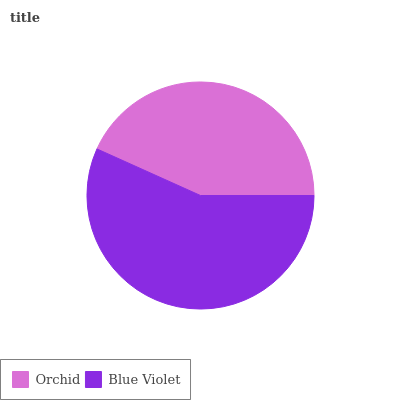Is Orchid the minimum?
Answer yes or no. Yes. Is Blue Violet the maximum?
Answer yes or no. Yes. Is Blue Violet the minimum?
Answer yes or no. No. Is Blue Violet greater than Orchid?
Answer yes or no. Yes. Is Orchid less than Blue Violet?
Answer yes or no. Yes. Is Orchid greater than Blue Violet?
Answer yes or no. No. Is Blue Violet less than Orchid?
Answer yes or no. No. Is Blue Violet the high median?
Answer yes or no. Yes. Is Orchid the low median?
Answer yes or no. Yes. Is Orchid the high median?
Answer yes or no. No. Is Blue Violet the low median?
Answer yes or no. No. 